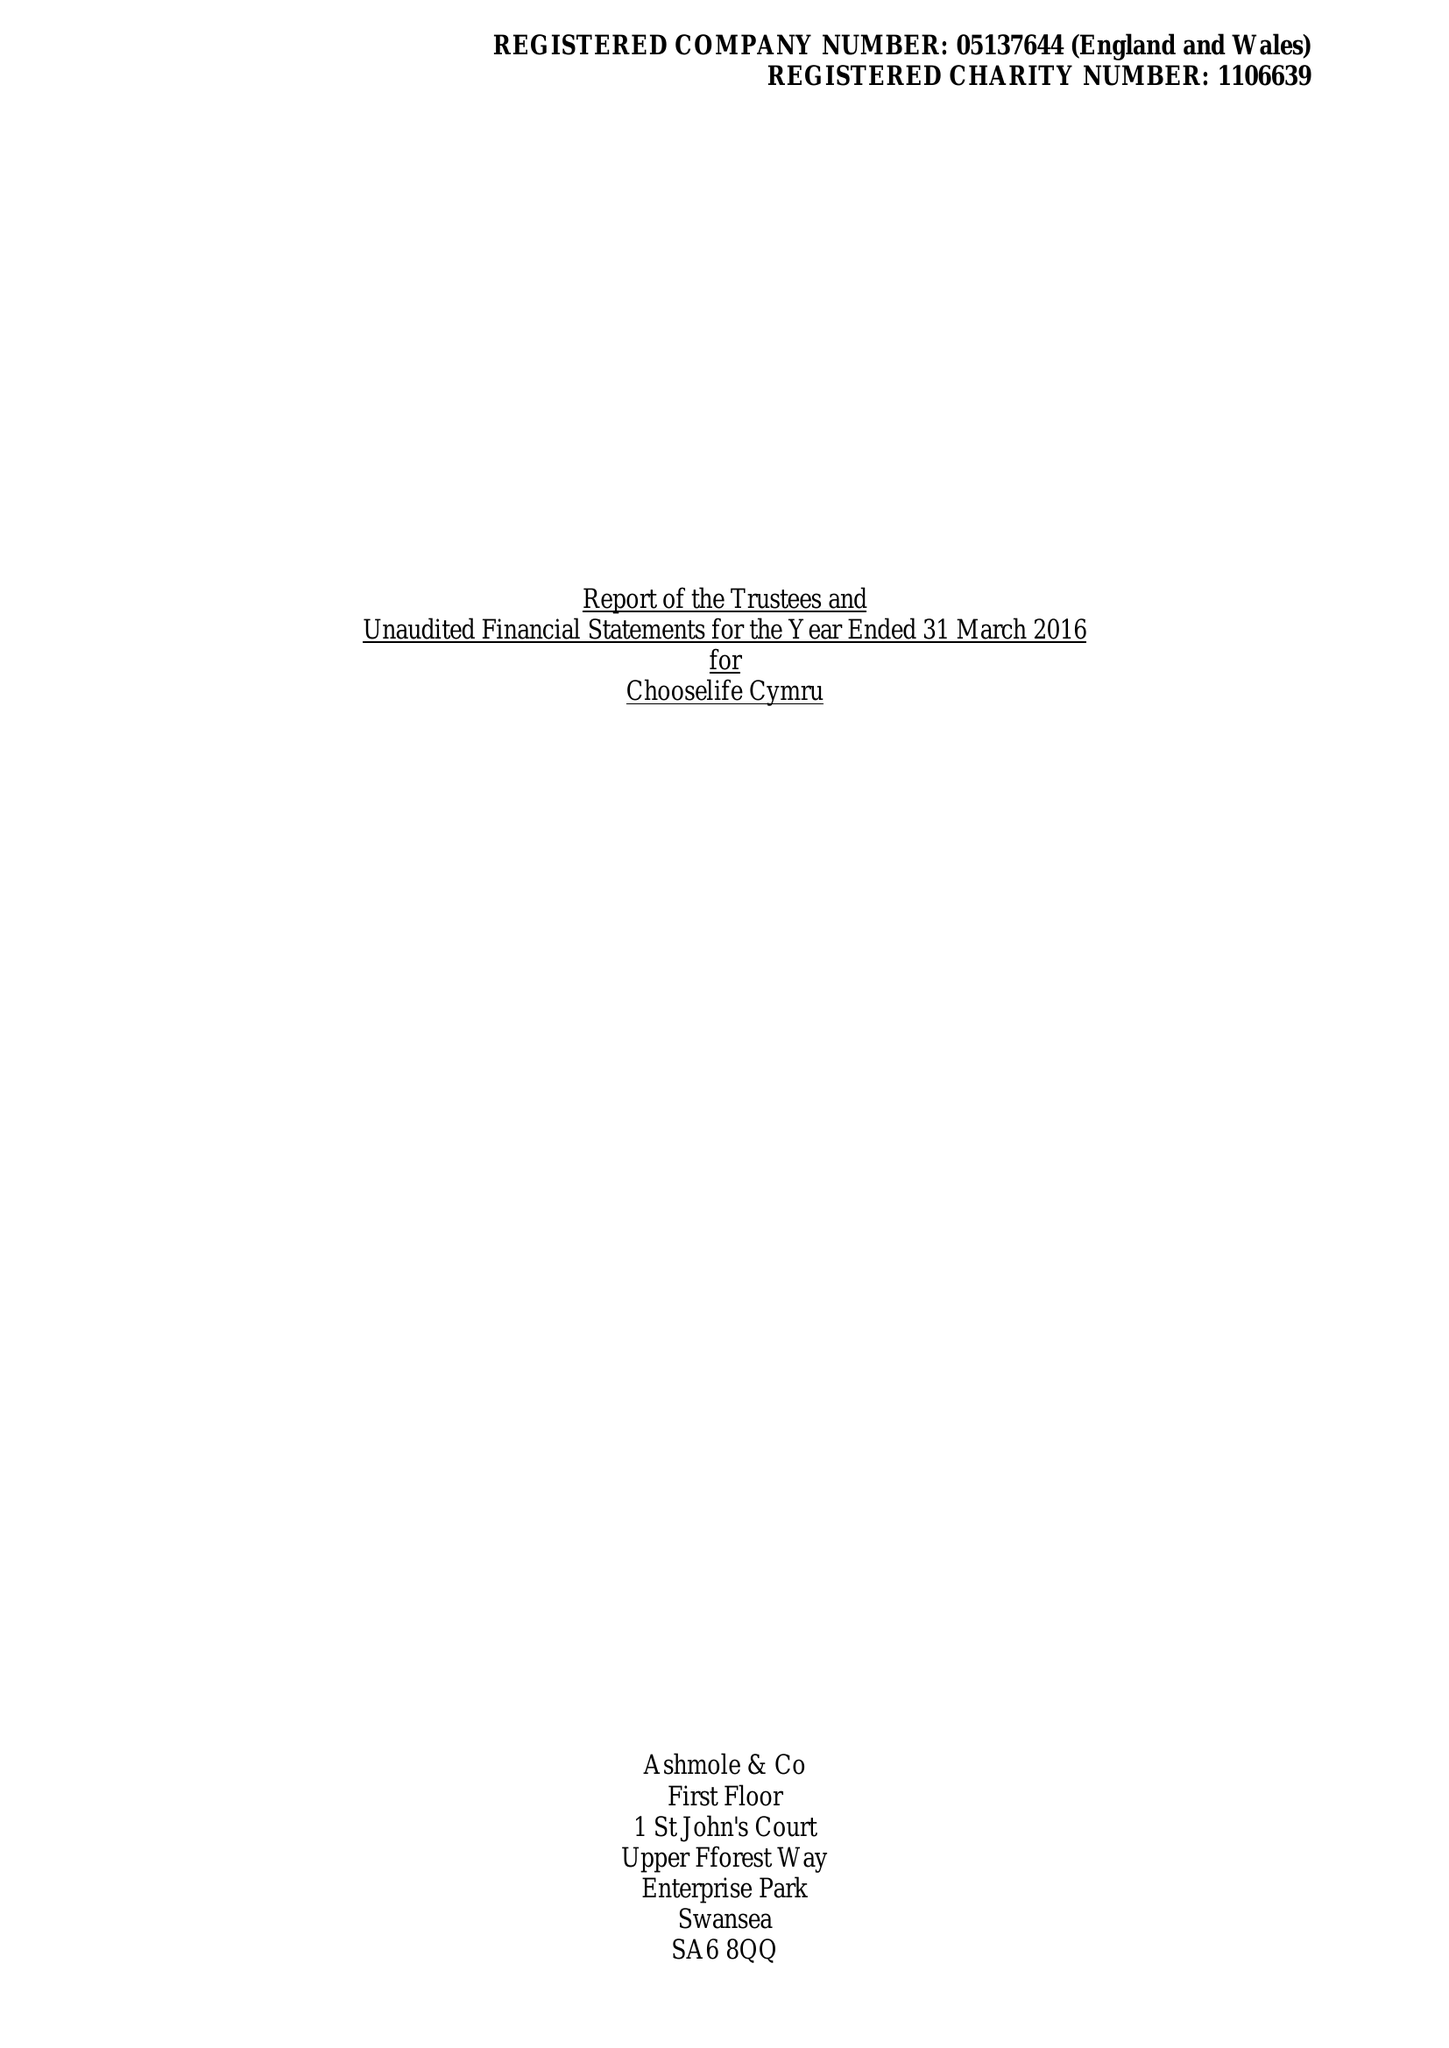What is the value for the report_date?
Answer the question using a single word or phrase. 2016-03-31 